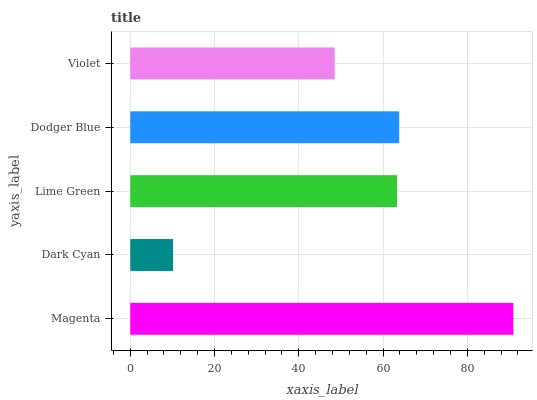Is Dark Cyan the minimum?
Answer yes or no. Yes. Is Magenta the maximum?
Answer yes or no. Yes. Is Lime Green the minimum?
Answer yes or no. No. Is Lime Green the maximum?
Answer yes or no. No. Is Lime Green greater than Dark Cyan?
Answer yes or no. Yes. Is Dark Cyan less than Lime Green?
Answer yes or no. Yes. Is Dark Cyan greater than Lime Green?
Answer yes or no. No. Is Lime Green less than Dark Cyan?
Answer yes or no. No. Is Lime Green the high median?
Answer yes or no. Yes. Is Lime Green the low median?
Answer yes or no. Yes. Is Magenta the high median?
Answer yes or no. No. Is Dark Cyan the low median?
Answer yes or no. No. 